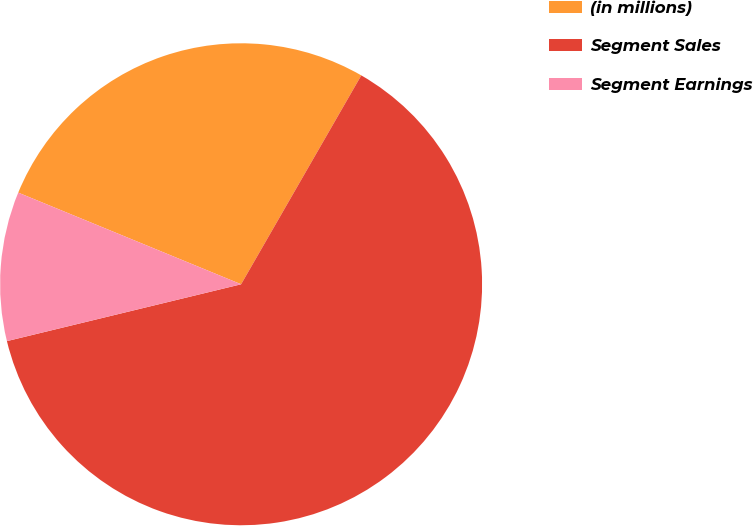Convert chart to OTSL. <chart><loc_0><loc_0><loc_500><loc_500><pie_chart><fcel>(in millions)<fcel>Segment Sales<fcel>Segment Earnings<nl><fcel>27.1%<fcel>62.9%<fcel>10.0%<nl></chart> 